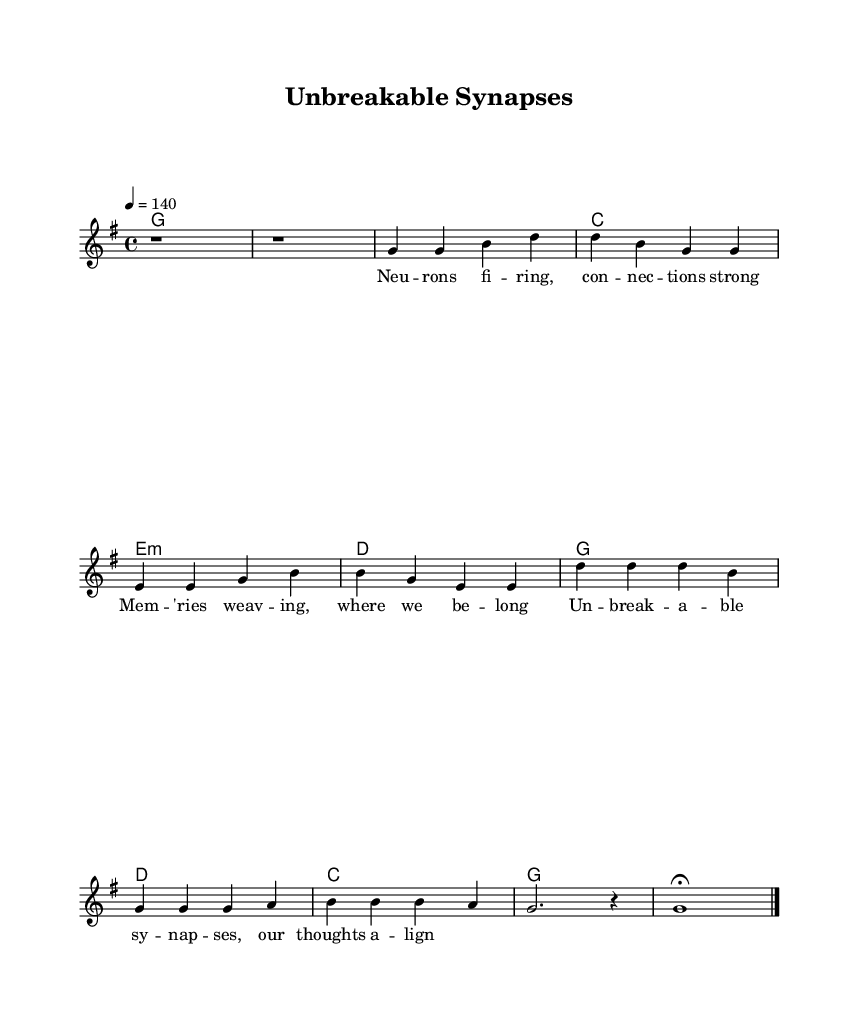What is the key signature of this music? The key signature is G major, which has one sharp (F#) indicated by the placement of the clef and the key signature marker.
Answer: G major What is the time signature of this music? The time signature is 4/4, which is displayed at the beginning of the score and indicates there are four beats per measure.
Answer: 4/4 What is the tempo marking for this piece? The tempo marking is 4 = 140, which indicates that there are 140 beats per minute, guiding the speed of the performance.
Answer: 140 How many measures are there in the verse section? The verse section consists of 4 measures, as can be counted from the melody line which includes four distinct groups of notes before the chorus starts.
Answer: 4 What is the primary theme reflected in the lyrics? The primary theme in the lyrics centers around resilience, conveying a message about strength and the human connection, as inferred from the words "unbreakable" and "memories weaving."
Answer: Resilience Which musical section follows the verse? The section that follows the verse is the chorus, which is indicated in the structure of the score by the separate melody and lyrics labeling.
Answer: Chorus 